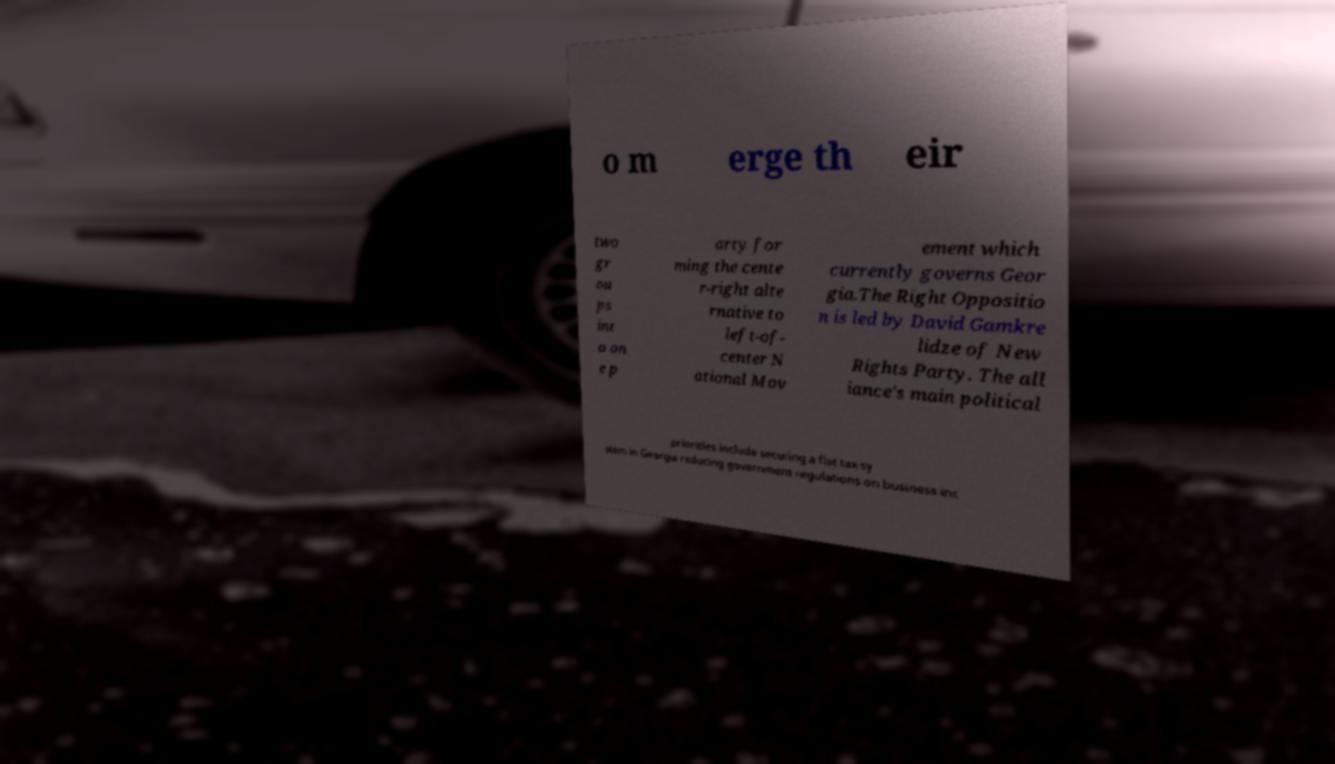Can you accurately transcribe the text from the provided image for me? o m erge th eir two gr ou ps int o on e p arty for ming the cente r-right alte rnative to left-of- center N ational Mov ement which currently governs Geor gia.The Right Oppositio n is led by David Gamkre lidze of New Rights Party. The all iance's main political priorities include securing a flat tax sy stem in Georgia reducing government regulations on business inc 